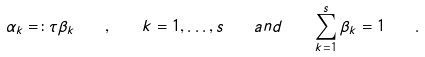Convert formula to latex. <formula><loc_0><loc_0><loc_500><loc_500>\alpha _ { k } = \colon \tau \beta _ { k } \quad , \quad k = 1 , \dots , s \quad a n d \quad \sum _ { k = 1 } ^ { s } \beta _ { k } = 1 \quad .</formula> 